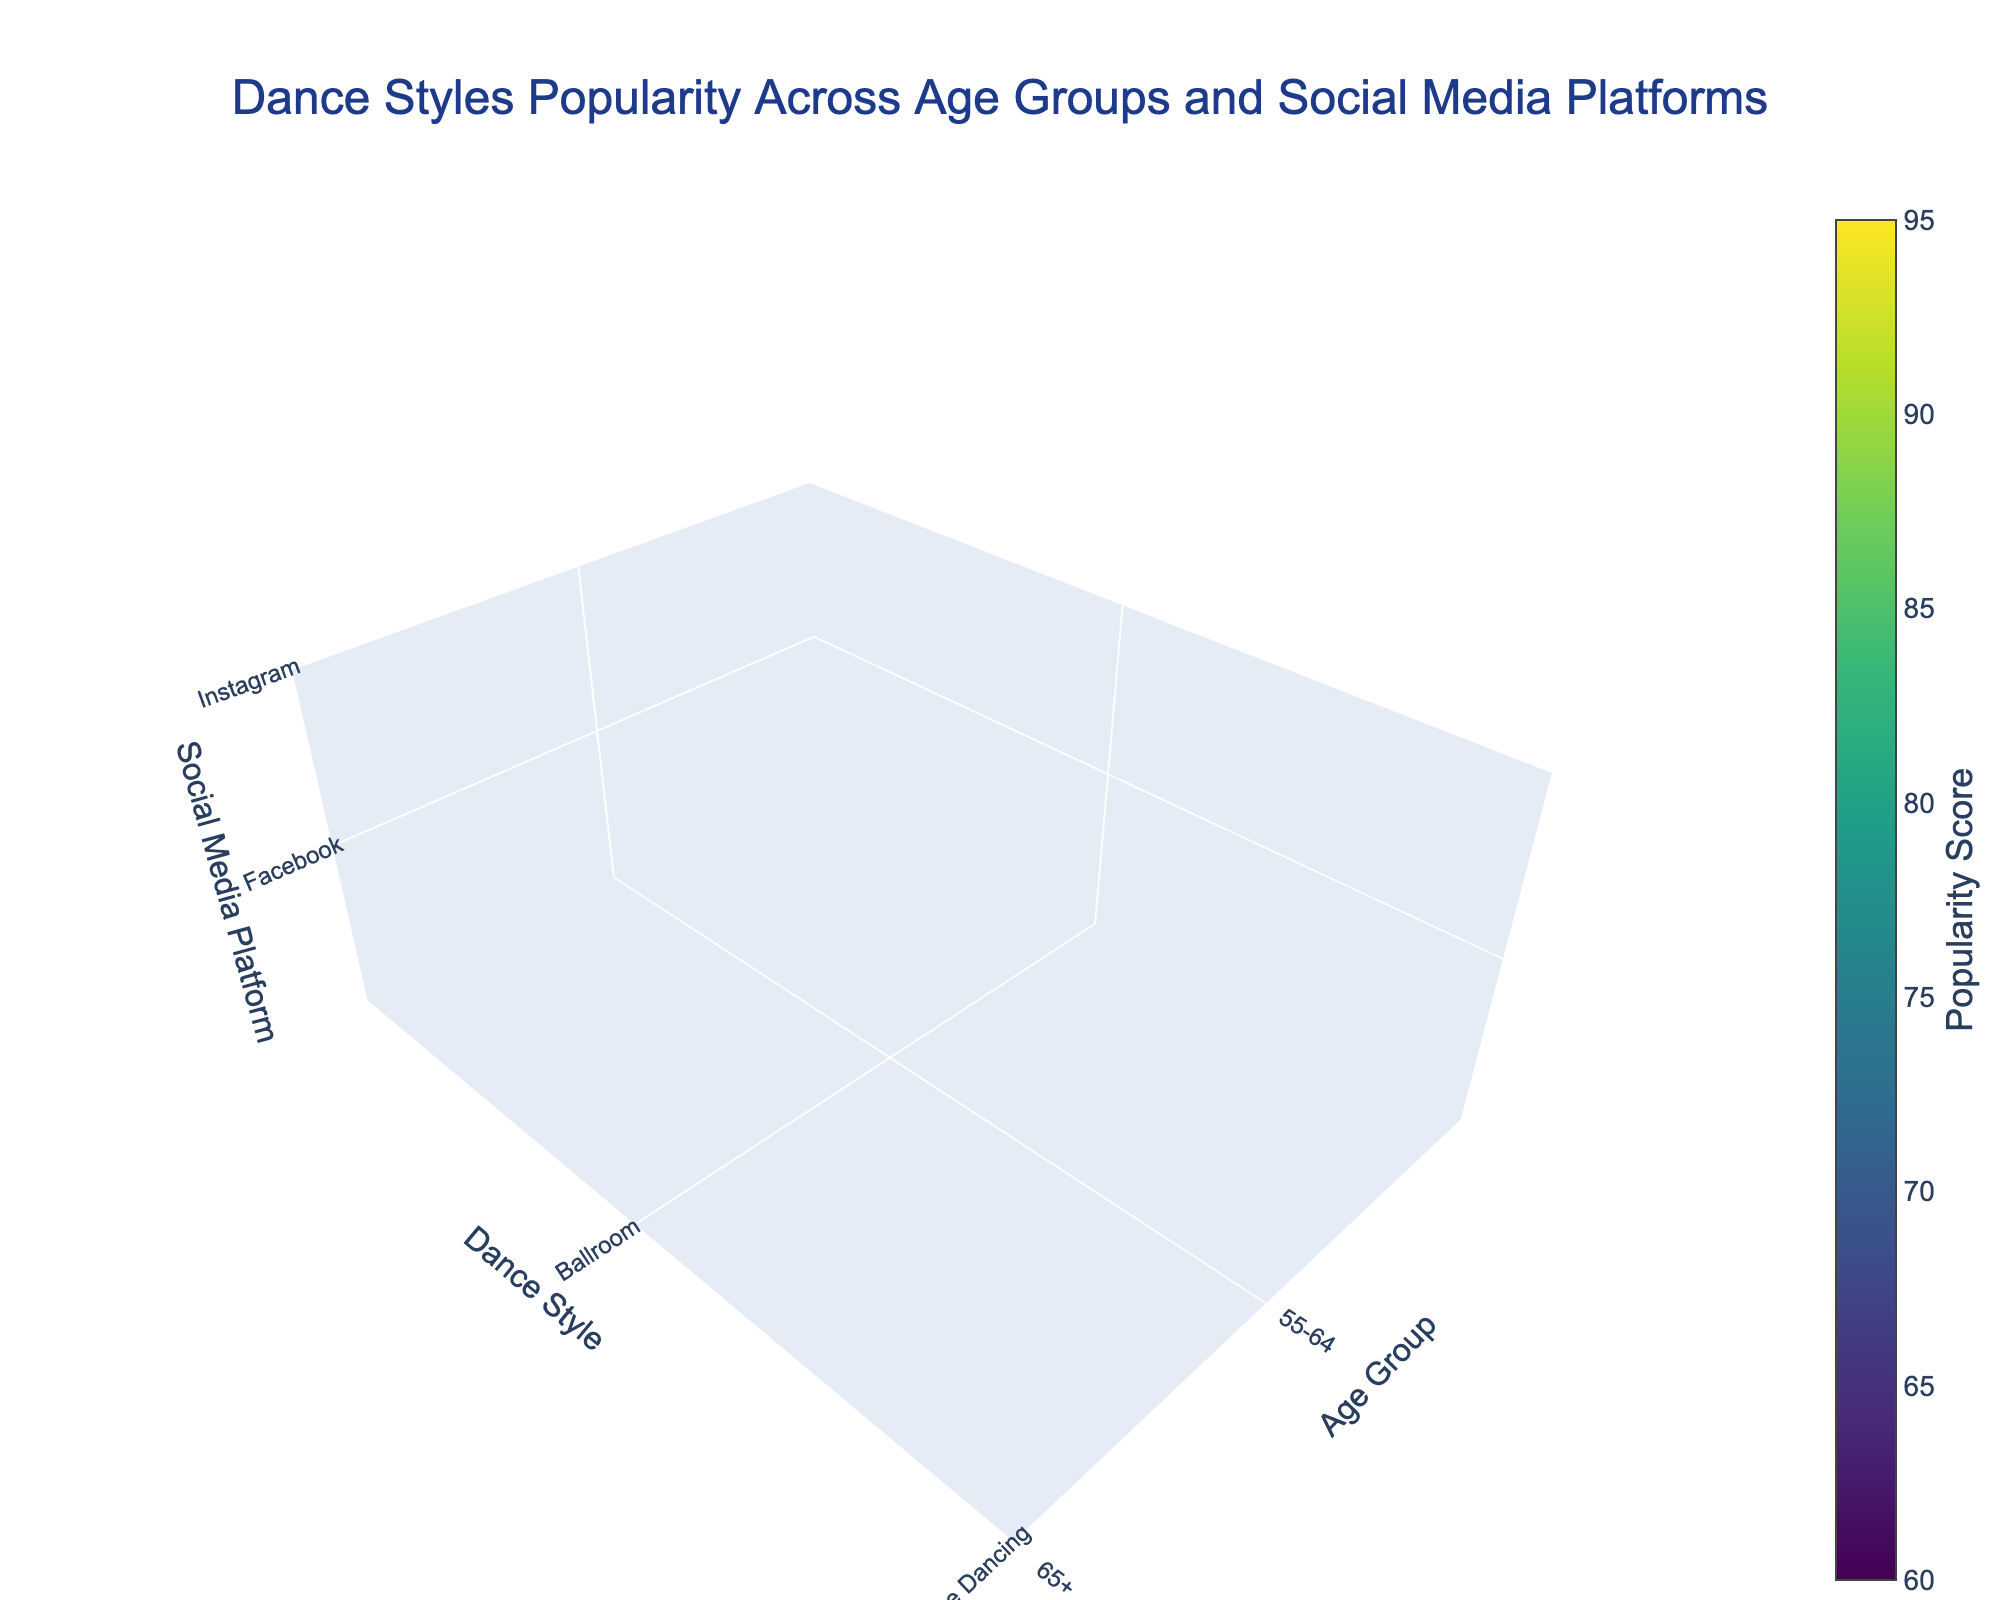What is the title of the 3D volume plot? The title of the plot can be found at the top.
Answer: Dance Styles Popularity Across Age Groups and Social Media Platforms How many age groups are represented in the plot? Count the distinct labels on the age group axis.
Answer: 5 Which dance style has the highest popularity score among the 18-24 age group? Find the highest value under the 18-24 age group across all dance styles on the popularity score axis.
Answer: Hip Hop Are there any dance styles with a popularity score of 0? Check if there are any points in the plot where the popularity score value is 0.
Answer: No What's the overall popularity trend for Ballroom dancing as the age group increases? Observe the popularity scores for Ballroom dancing across all age groups and identify any increasing or decreasing pattern.
Answer: Increasing Which social media platform is the most popular for dance styles among the 35-44 age group? Find the social media platform with the highest cumulative popularity score for all dance styles under the 35-44 age group.
Answer: TikTok How does the popularity of Line Dancing on Facebook compare between the 55-64 and 65+ age groups? Compare the popularity scores for Line Dancing on Facebook between the two specified age groups.
Answer: Higher in 65+ Which dance style has the lowest popularity score on Instagram? Find the minimum popularity score for all dance styles on Instagram.
Answer: Zumba What is the difference in popularity score between Hip Hop on TikTok for the 18-24 and 25-34 age groups? Subtract the popularity score of Hip Hop on TikTok for the 25-34 age group from that of the 18-24 age group.
Answer: 3 Is YouTube equally popular for Zumba across all age groups? Compare the popularity scores for Zumba on YouTube across all age groups and determine if they are equal.
Answer: No 